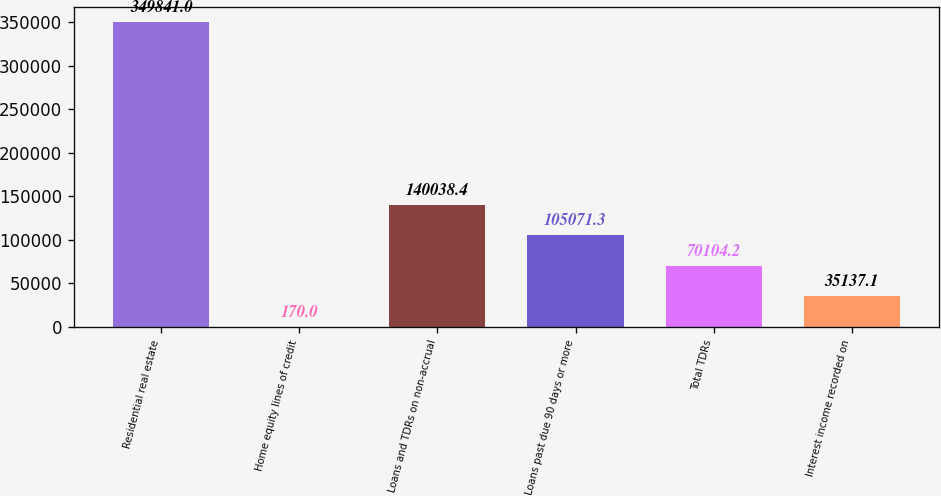Convert chart to OTSL. <chart><loc_0><loc_0><loc_500><loc_500><bar_chart><fcel>Residential real estate<fcel>Home equity lines of credit<fcel>Loans and TDRs on non-accrual<fcel>Loans past due 90 days or more<fcel>Total TDRs<fcel>Interest income recorded on<nl><fcel>349841<fcel>170<fcel>140038<fcel>105071<fcel>70104.2<fcel>35137.1<nl></chart> 